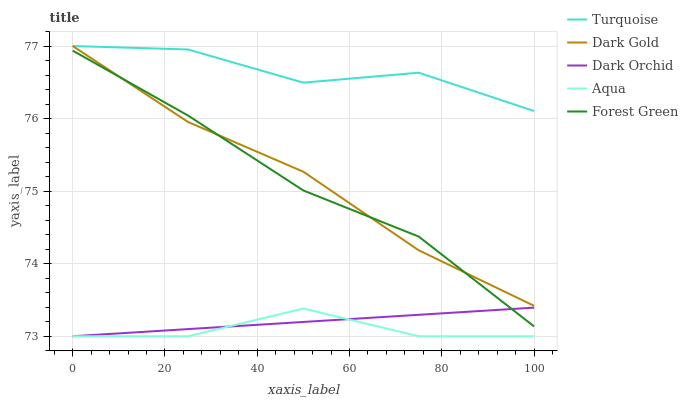Does Aqua have the minimum area under the curve?
Answer yes or no. Yes. Does Turquoise have the maximum area under the curve?
Answer yes or no. Yes. Does Forest Green have the minimum area under the curve?
Answer yes or no. No. Does Forest Green have the maximum area under the curve?
Answer yes or no. No. Is Dark Orchid the smoothest?
Answer yes or no. Yes. Is Turquoise the roughest?
Answer yes or no. Yes. Is Aqua the smoothest?
Answer yes or no. No. Is Aqua the roughest?
Answer yes or no. No. Does Aqua have the lowest value?
Answer yes or no. Yes. Does Forest Green have the lowest value?
Answer yes or no. No. Does Dark Gold have the highest value?
Answer yes or no. Yes. Does Forest Green have the highest value?
Answer yes or no. No. Is Dark Orchid less than Dark Gold?
Answer yes or no. Yes. Is Turquoise greater than Aqua?
Answer yes or no. Yes. Does Forest Green intersect Dark Orchid?
Answer yes or no. Yes. Is Forest Green less than Dark Orchid?
Answer yes or no. No. Is Forest Green greater than Dark Orchid?
Answer yes or no. No. Does Dark Orchid intersect Dark Gold?
Answer yes or no. No. 